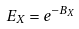Convert formula to latex. <formula><loc_0><loc_0><loc_500><loc_500>E _ { X } = e ^ { - B _ { X } }</formula> 